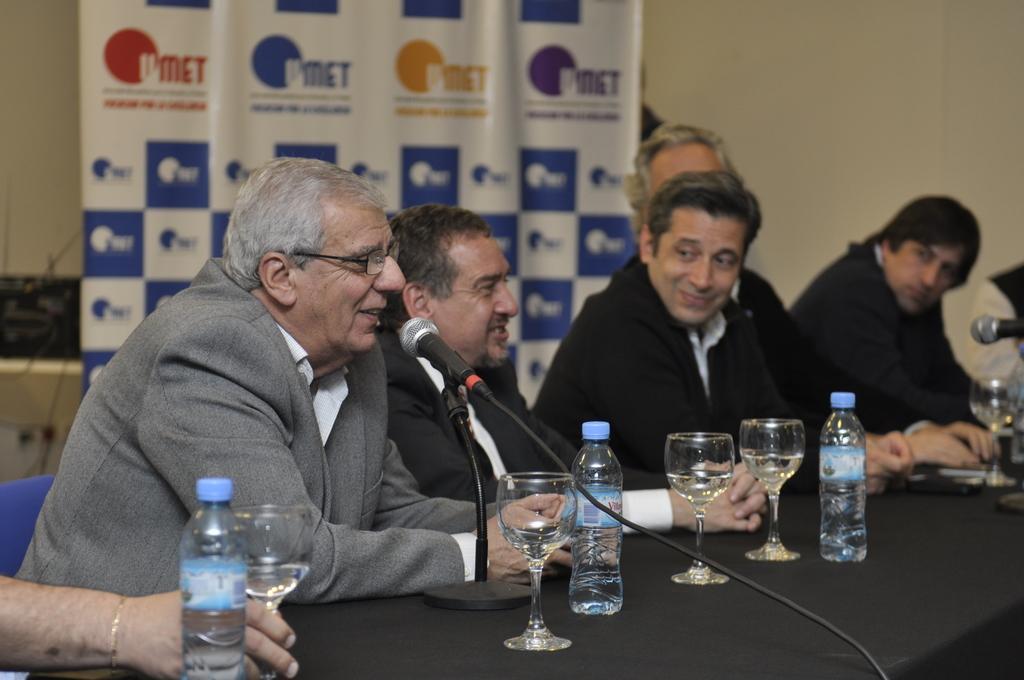Can you describe this image briefly? There are many persons sitting. In front of them there is a table. On the table there are glasses, bottles, mics and mic stand. In the background there is a banner and a wall. 